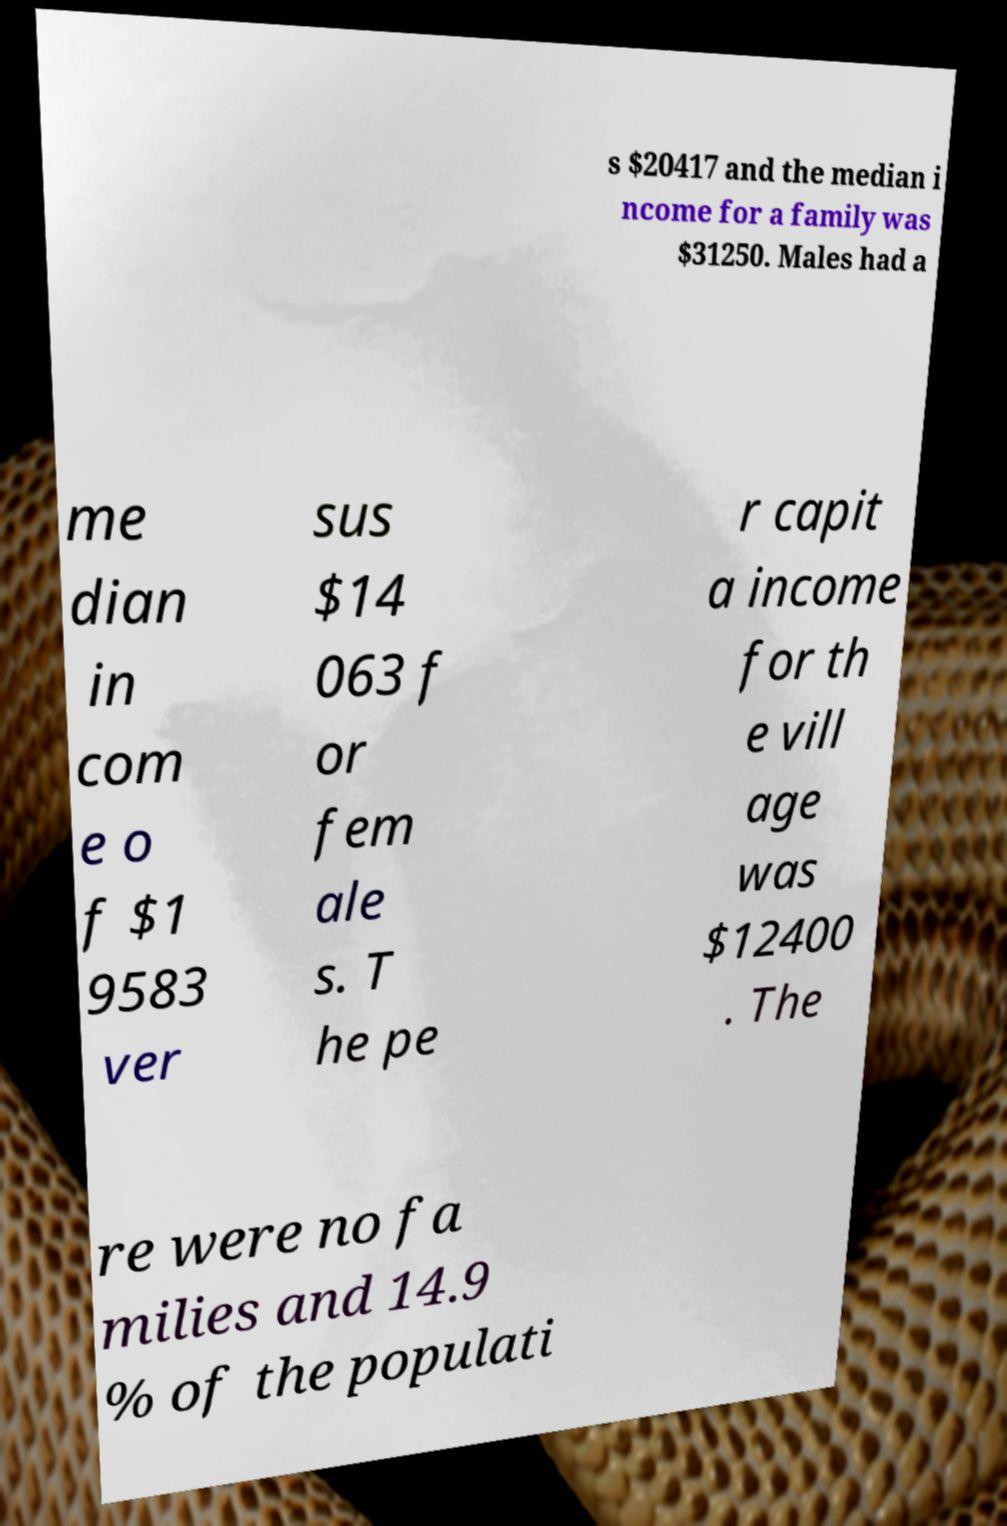I need the written content from this picture converted into text. Can you do that? s $20417 and the median i ncome for a family was $31250. Males had a me dian in com e o f $1 9583 ver sus $14 063 f or fem ale s. T he pe r capit a income for th e vill age was $12400 . The re were no fa milies and 14.9 % of the populati 